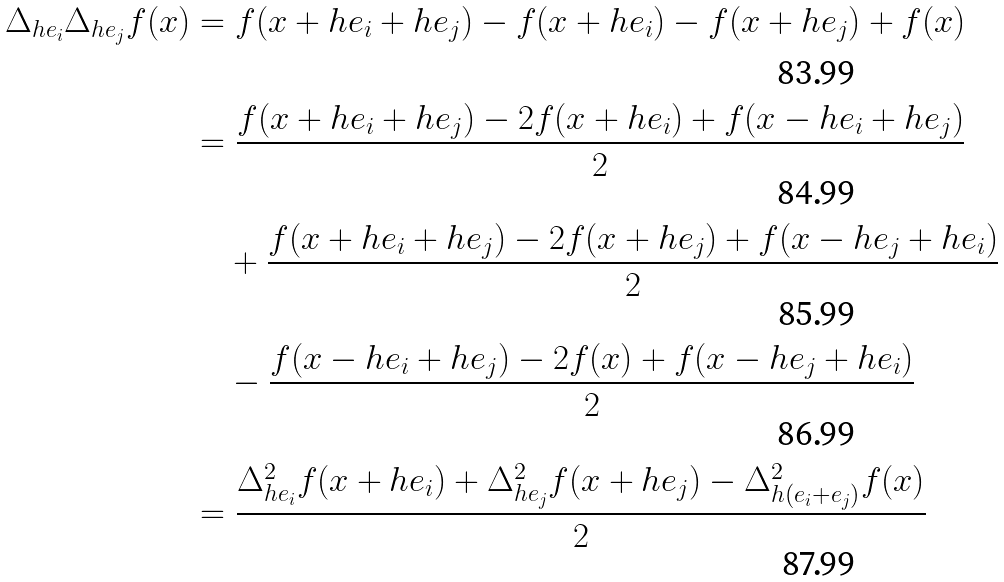<formula> <loc_0><loc_0><loc_500><loc_500>\Delta _ { h e _ { i } } \Delta _ { h e _ { j } } f ( x ) & = f ( x + h e _ { i } + h e _ { j } ) - f ( x + h e _ { i } ) - f ( x + h e _ { j } ) + f ( x ) \\ & = \frac { f ( x + h e _ { i } + h e _ { j } ) - 2 f ( x + h e _ { i } ) + f ( x - h e _ { i } + h e _ { j } ) } { 2 } \\ & \quad + \frac { f ( x + h e _ { i } + h e _ { j } ) - 2 f ( x + h e _ { j } ) + f ( x - h e _ { j } + h e _ { i } ) } { 2 } \\ & \quad - \frac { f ( x - h e _ { i } + h e _ { j } ) - 2 f ( x ) + f ( x - h e _ { j } + h e _ { i } ) } { 2 } \\ & = \frac { \Delta _ { h e _ { i } } ^ { 2 } f ( x + h e _ { i } ) + \Delta _ { h e _ { j } } ^ { 2 } f ( x + h e _ { j } ) - \Delta _ { h ( e _ { i } + e _ { j } ) } ^ { 2 } f ( x ) } { 2 }</formula> 